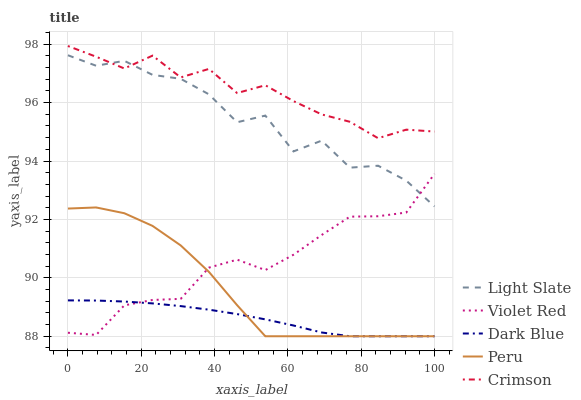Does Dark Blue have the minimum area under the curve?
Answer yes or no. Yes. Does Crimson have the maximum area under the curve?
Answer yes or no. Yes. Does Violet Red have the minimum area under the curve?
Answer yes or no. No. Does Violet Red have the maximum area under the curve?
Answer yes or no. No. Is Dark Blue the smoothest?
Answer yes or no. Yes. Is Light Slate the roughest?
Answer yes or no. Yes. Is Violet Red the smoothest?
Answer yes or no. No. Is Violet Red the roughest?
Answer yes or no. No. Does Dark Blue have the lowest value?
Answer yes or no. Yes. Does Violet Red have the lowest value?
Answer yes or no. No. Does Crimson have the highest value?
Answer yes or no. Yes. Does Violet Red have the highest value?
Answer yes or no. No. Is Violet Red less than Crimson?
Answer yes or no. Yes. Is Light Slate greater than Peru?
Answer yes or no. Yes. Does Light Slate intersect Violet Red?
Answer yes or no. Yes. Is Light Slate less than Violet Red?
Answer yes or no. No. Is Light Slate greater than Violet Red?
Answer yes or no. No. Does Violet Red intersect Crimson?
Answer yes or no. No. 